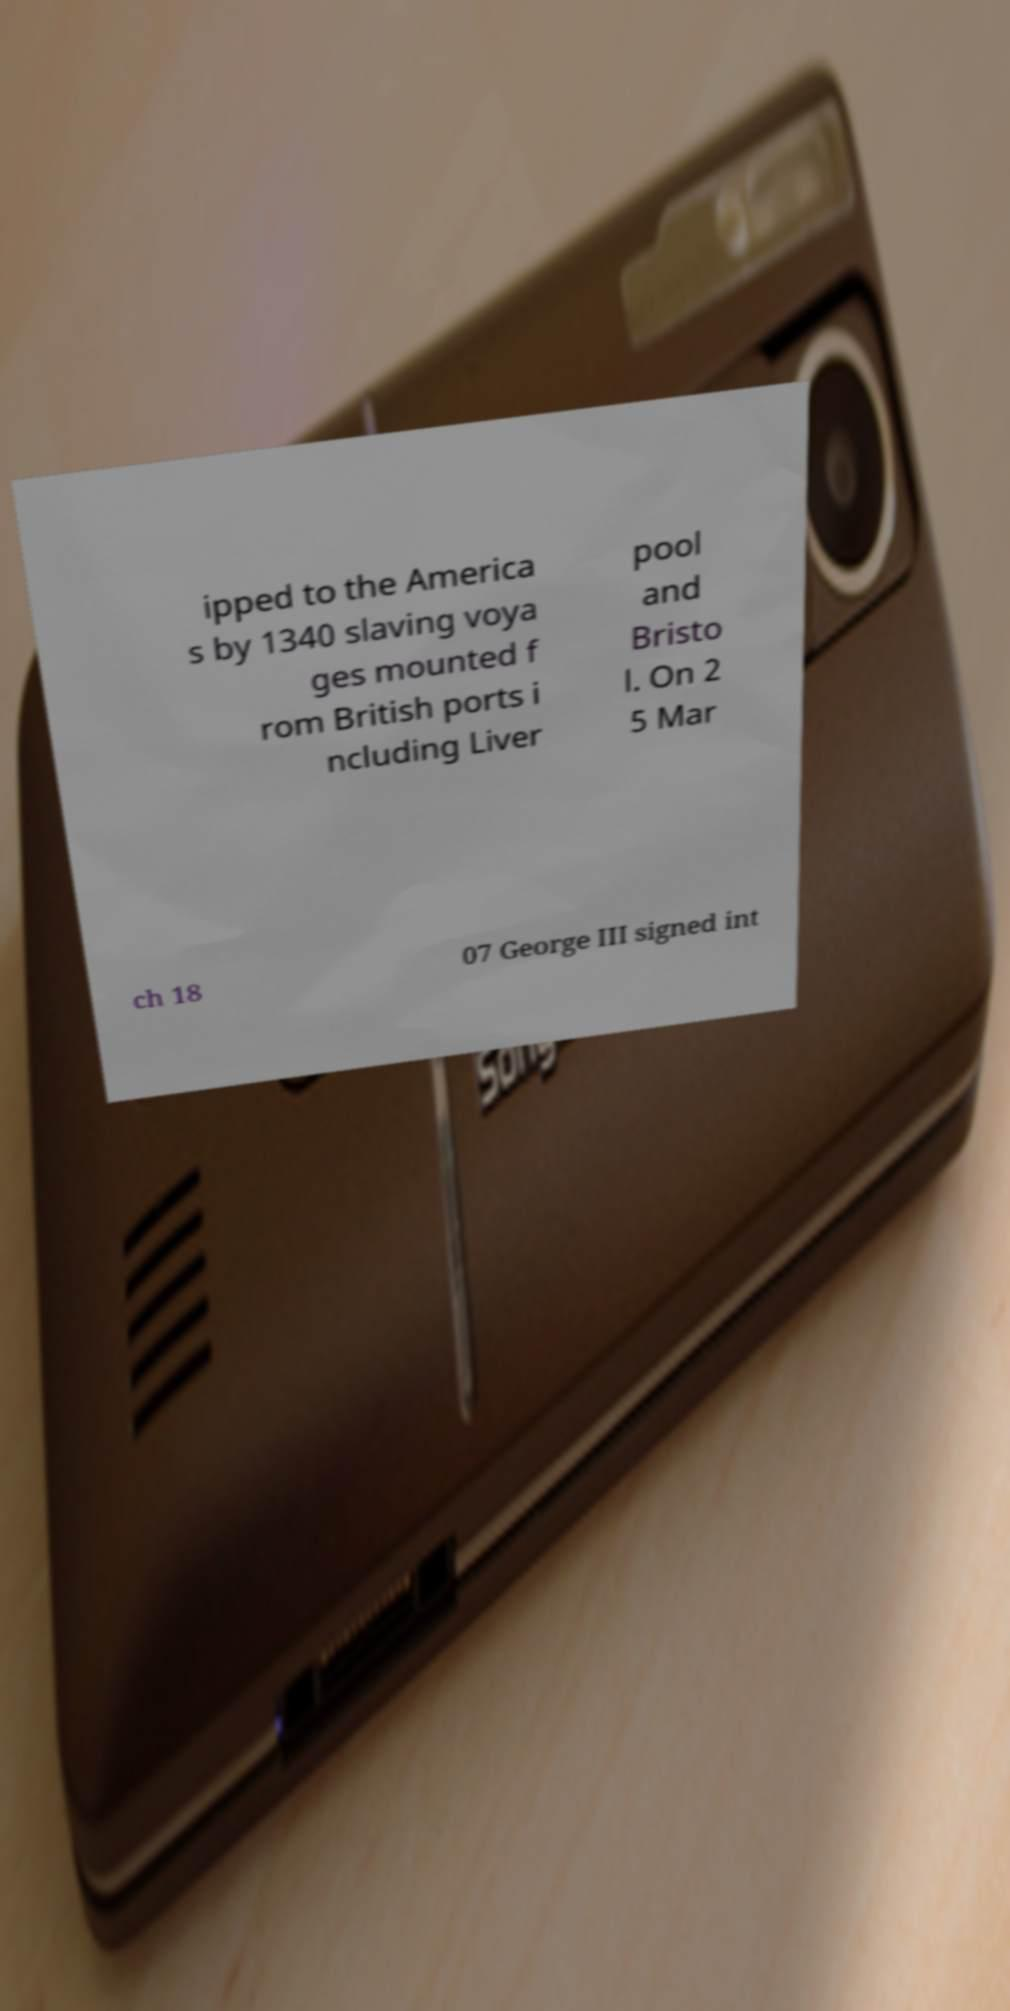Please read and relay the text visible in this image. What does it say? ipped to the America s by 1340 slaving voya ges mounted f rom British ports i ncluding Liver pool and Bristo l. On 2 5 Mar ch 18 07 George III signed int 